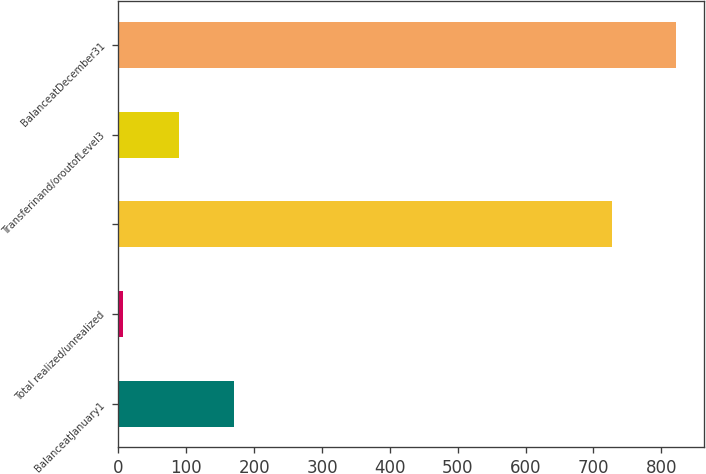Convert chart to OTSL. <chart><loc_0><loc_0><loc_500><loc_500><bar_chart><fcel>BalanceatJanuary1<fcel>Total realized/unrealized<fcel>Unnamed: 2<fcel>Transferinand/oroutofLevel3<fcel>BalanceatDecember31<nl><fcel>170<fcel>7<fcel>727<fcel>88.5<fcel>822<nl></chart> 